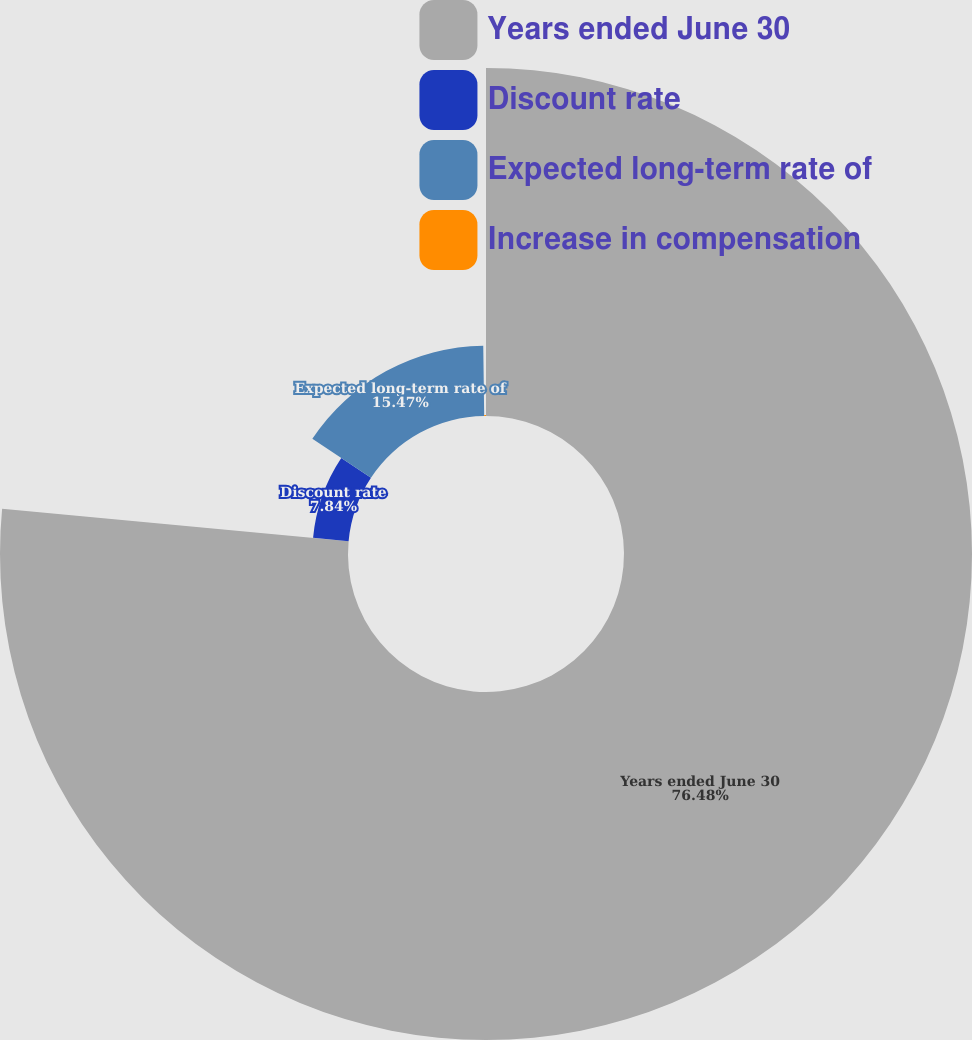Convert chart. <chart><loc_0><loc_0><loc_500><loc_500><pie_chart><fcel>Years ended June 30<fcel>Discount rate<fcel>Expected long-term rate of<fcel>Increase in compensation<nl><fcel>76.49%<fcel>7.84%<fcel>15.47%<fcel>0.21%<nl></chart> 